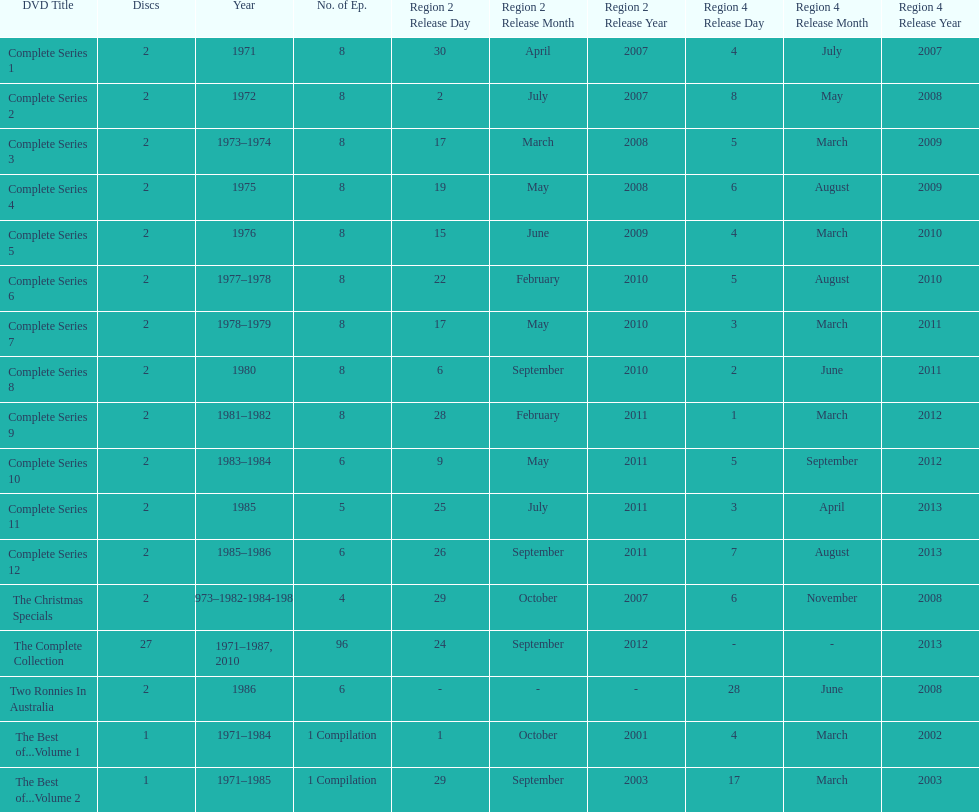Dvd shorter than 5 episodes The Christmas Specials. 